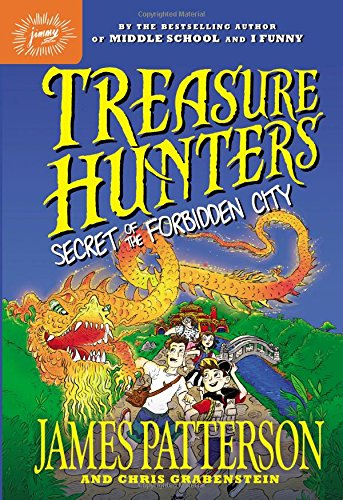What is the title of this book? The title of the book is 'Treasure Hunters: Secret of the Forbidden City,' suggesting an adventurous plot involving a search for hidden treasures. 